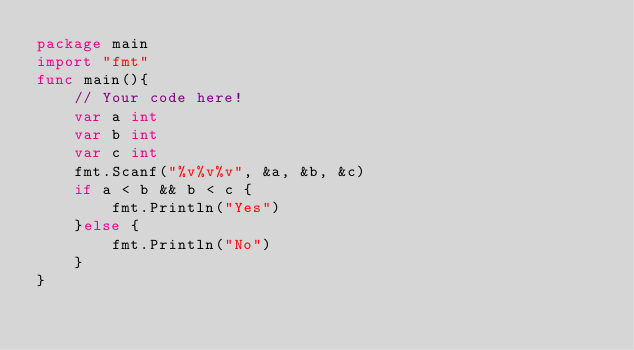Convert code to text. <code><loc_0><loc_0><loc_500><loc_500><_Go_>package main
import "fmt"
func main(){
    // Your code here!
    var a int
    var b int
    var c int
    fmt.Scanf("%v%v%v", &a, &b, &c)
    if a < b && b < c {
        fmt.Println("Yes")
    }else {
        fmt.Println("No")
    }
}
</code> 